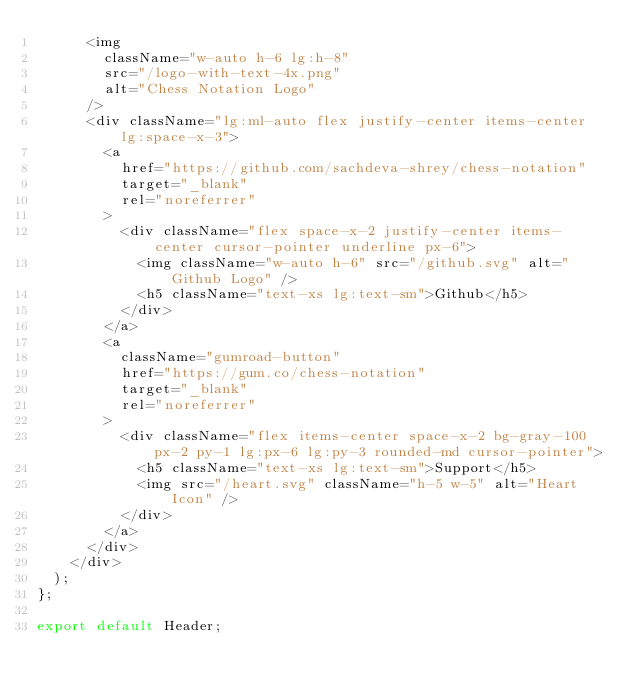<code> <loc_0><loc_0><loc_500><loc_500><_TypeScript_>      <img
        className="w-auto h-6 lg:h-8"
        src="/logo-with-text-4x.png"
        alt="Chess Notation Logo"
      />
      <div className="lg:ml-auto flex justify-center items-center lg:space-x-3">
        <a
          href="https://github.com/sachdeva-shrey/chess-notation"
          target="_blank"
          rel="noreferrer"
        >
          <div className="flex space-x-2 justify-center items-center cursor-pointer underline px-6">
            <img className="w-auto h-6" src="/github.svg" alt="Github Logo" />
            <h5 className="text-xs lg:text-sm">Github</h5>
          </div>
        </a>
        <a
          className="gumroad-button"
          href="https://gum.co/chess-notation"
          target="_blank"
          rel="noreferrer"
        >
          <div className="flex items-center space-x-2 bg-gray-100 px-2 py-1 lg:px-6 lg:py-3 rounded-md cursor-pointer">
            <h5 className="text-xs lg:text-sm">Support</h5>
            <img src="/heart.svg" className="h-5 w-5" alt="Heart Icon" />
          </div>
        </a>
      </div>
    </div>
  );
};

export default Header;
</code> 